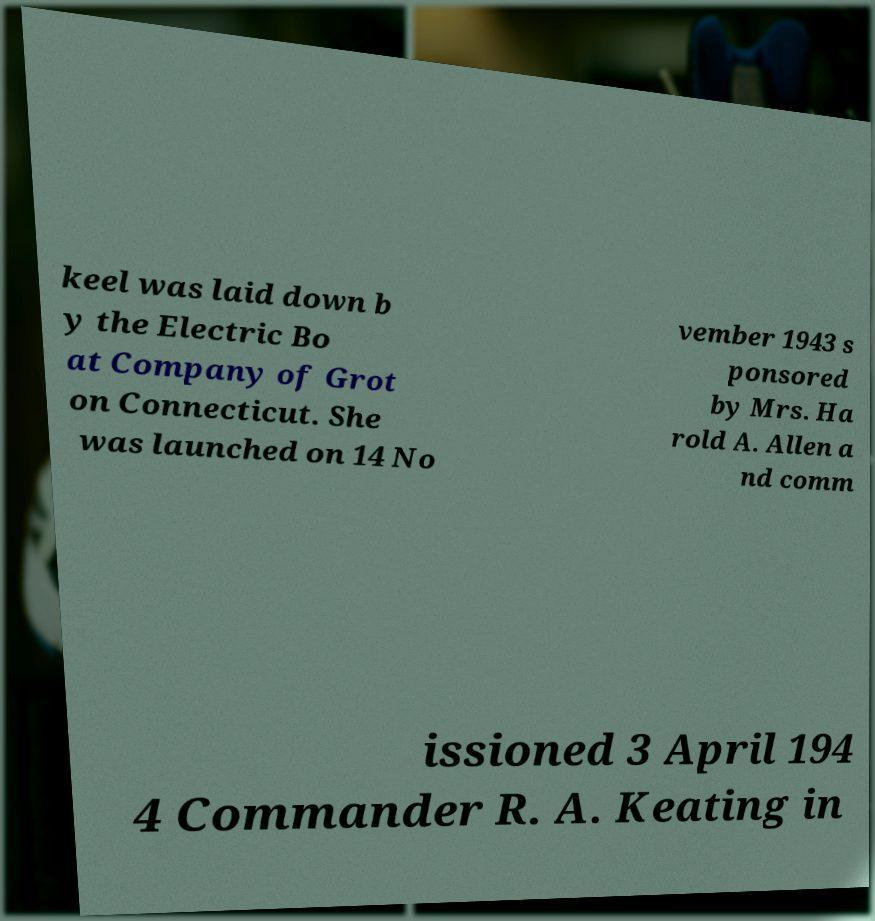Please read and relay the text visible in this image. What does it say? keel was laid down b y the Electric Bo at Company of Grot on Connecticut. She was launched on 14 No vember 1943 s ponsored by Mrs. Ha rold A. Allen a nd comm issioned 3 April 194 4 Commander R. A. Keating in 